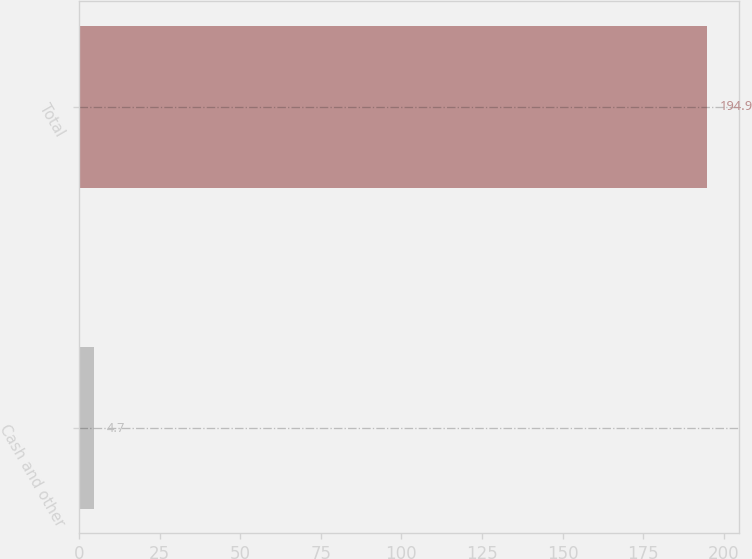Convert chart to OTSL. <chart><loc_0><loc_0><loc_500><loc_500><bar_chart><fcel>Cash and other<fcel>Total<nl><fcel>4.7<fcel>194.9<nl></chart> 